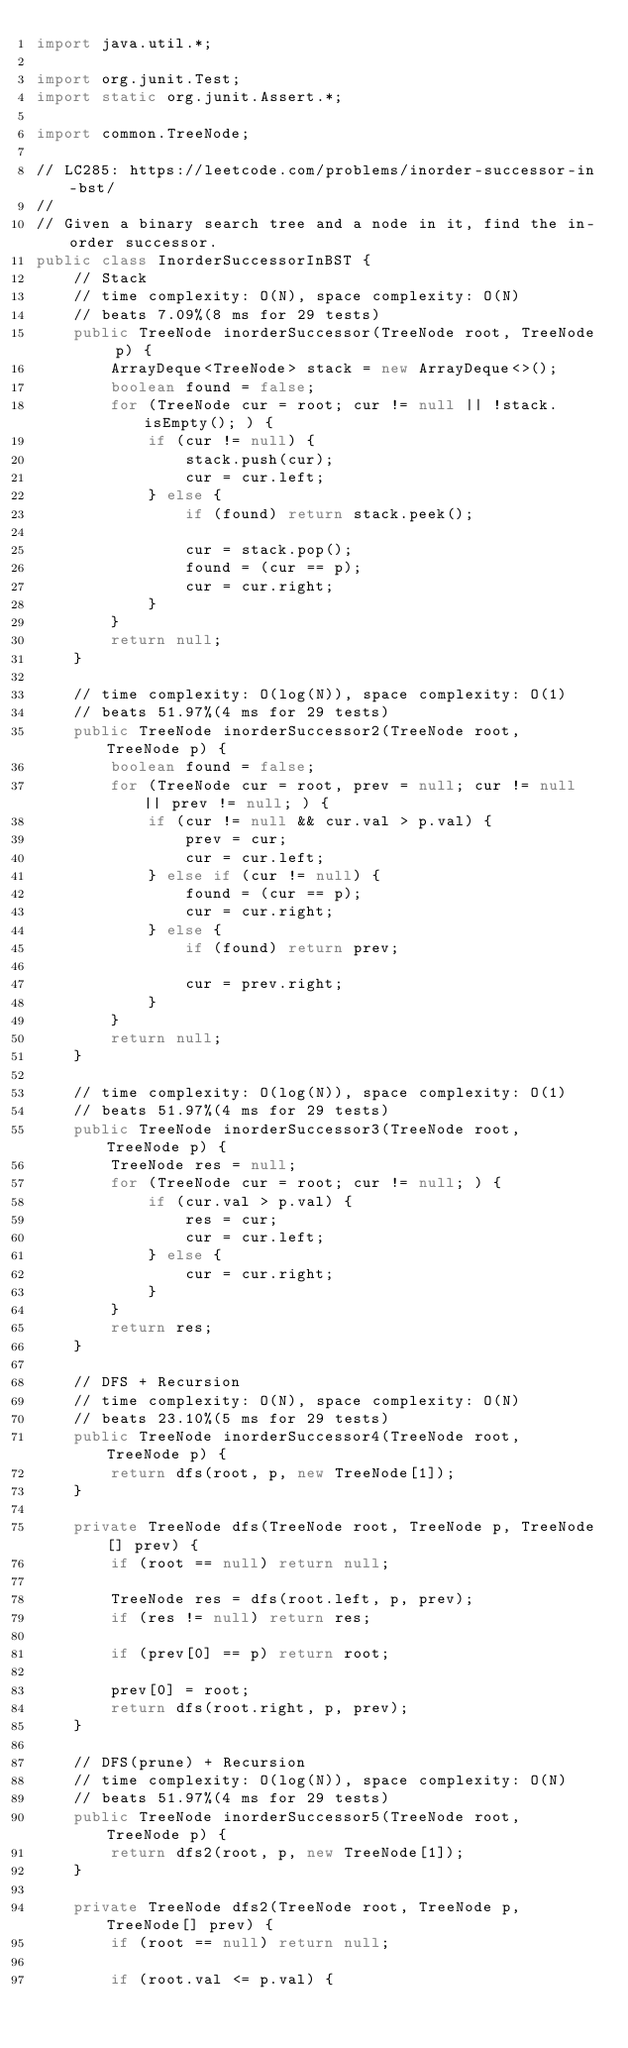Convert code to text. <code><loc_0><loc_0><loc_500><loc_500><_Java_>import java.util.*;

import org.junit.Test;
import static org.junit.Assert.*;

import common.TreeNode;

// LC285: https://leetcode.com/problems/inorder-successor-in-bst/
//
// Given a binary search tree and a node in it, find the in-order successor.
public class InorderSuccessorInBST {
    // Stack
    // time complexity: O(N), space complexity: O(N)
    // beats 7.09%(8 ms for 29 tests)
    public TreeNode inorderSuccessor(TreeNode root, TreeNode p) {
        ArrayDeque<TreeNode> stack = new ArrayDeque<>();
        boolean found = false;
        for (TreeNode cur = root; cur != null || !stack.isEmpty(); ) {
            if (cur != null) {
                stack.push(cur);
                cur = cur.left;
            } else {
                if (found) return stack.peek();

                cur = stack.pop();
                found = (cur == p);
                cur = cur.right;
            }
        }
        return null;
    }

    // time complexity: O(log(N)), space complexity: O(1)
    // beats 51.97%(4 ms for 29 tests)
    public TreeNode inorderSuccessor2(TreeNode root, TreeNode p) {
        boolean found = false;
        for (TreeNode cur = root, prev = null; cur != null || prev != null; ) {
            if (cur != null && cur.val > p.val) {
                prev = cur;
                cur = cur.left;
            } else if (cur != null) {
                found = (cur == p);
                cur = cur.right;
            } else {
                if (found) return prev;

                cur = prev.right;
            }
        }
        return null;
    }

    // time complexity: O(log(N)), space complexity: O(1)
    // beats 51.97%(4 ms for 29 tests)
    public TreeNode inorderSuccessor3(TreeNode root, TreeNode p) {
        TreeNode res = null;
        for (TreeNode cur = root; cur != null; ) {
            if (cur.val > p.val) {
                res = cur;
                cur = cur.left;
            } else {
                cur = cur.right;
            }
        }
        return res;
    }

    // DFS + Recursion
    // time complexity: O(N), space complexity: O(N)
    // beats 23.10%(5 ms for 29 tests)
    public TreeNode inorderSuccessor4(TreeNode root, TreeNode p) {
        return dfs(root, p, new TreeNode[1]);
    }

    private TreeNode dfs(TreeNode root, TreeNode p, TreeNode[] prev) {
        if (root == null) return null;

        TreeNode res = dfs(root.left, p, prev);
        if (res != null) return res;

        if (prev[0] == p) return root;

        prev[0] = root;
        return dfs(root.right, p, prev);
    }

    // DFS(prune) + Recursion
    // time complexity: O(log(N)), space complexity: O(N)
    // beats 51.97%(4 ms for 29 tests)
    public TreeNode inorderSuccessor5(TreeNode root, TreeNode p) {
        return dfs2(root, p, new TreeNode[1]);
    }

    private TreeNode dfs2(TreeNode root, TreeNode p, TreeNode[] prev) {
        if (root == null) return null;

        if (root.val <= p.val) {</code> 